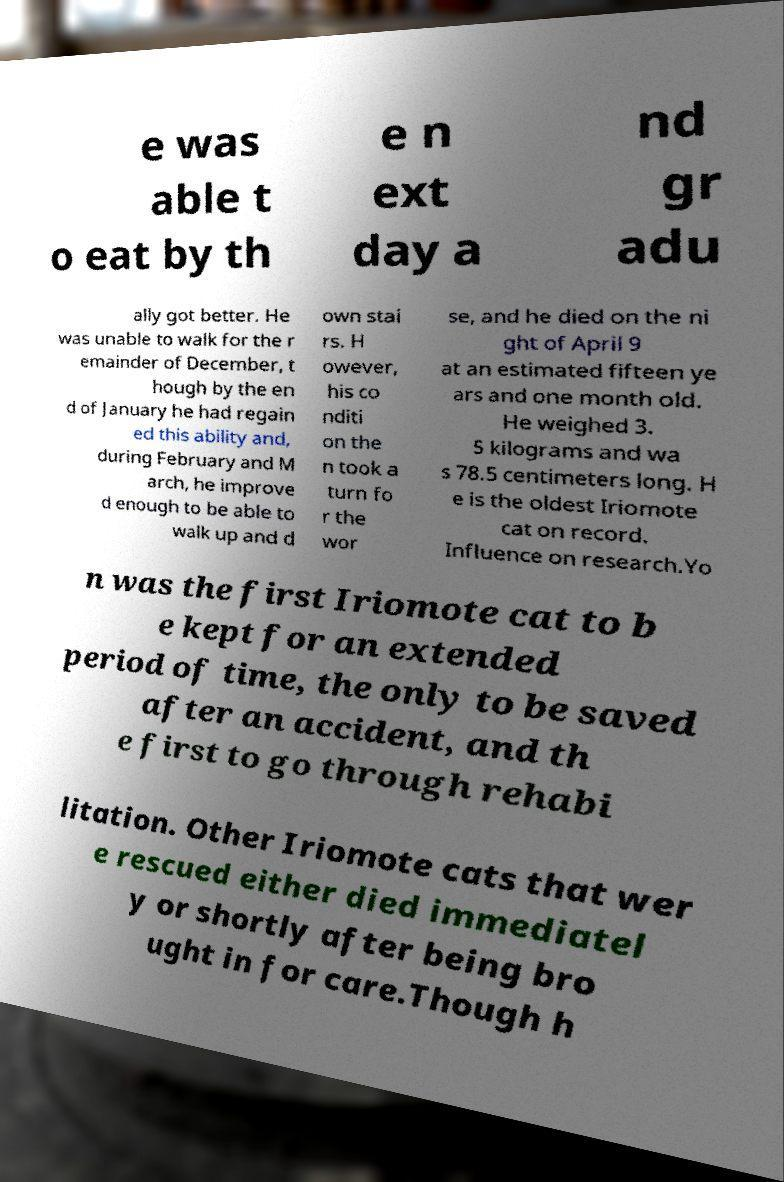What messages or text are displayed in this image? I need them in a readable, typed format. e was able t o eat by th e n ext day a nd gr adu ally got better. He was unable to walk for the r emainder of December, t hough by the en d of January he had regain ed this ability and, during February and M arch, he improve d enough to be able to walk up and d own stai rs. H owever, his co nditi on the n took a turn fo r the wor se, and he died on the ni ght of April 9 at an estimated fifteen ye ars and one month old. He weighed 3. 5 kilograms and wa s 78.5 centimeters long. H e is the oldest Iriomote cat on record. Influence on research.Yo n was the first Iriomote cat to b e kept for an extended period of time, the only to be saved after an accident, and th e first to go through rehabi litation. Other Iriomote cats that wer e rescued either died immediatel y or shortly after being bro ught in for care.Though h 